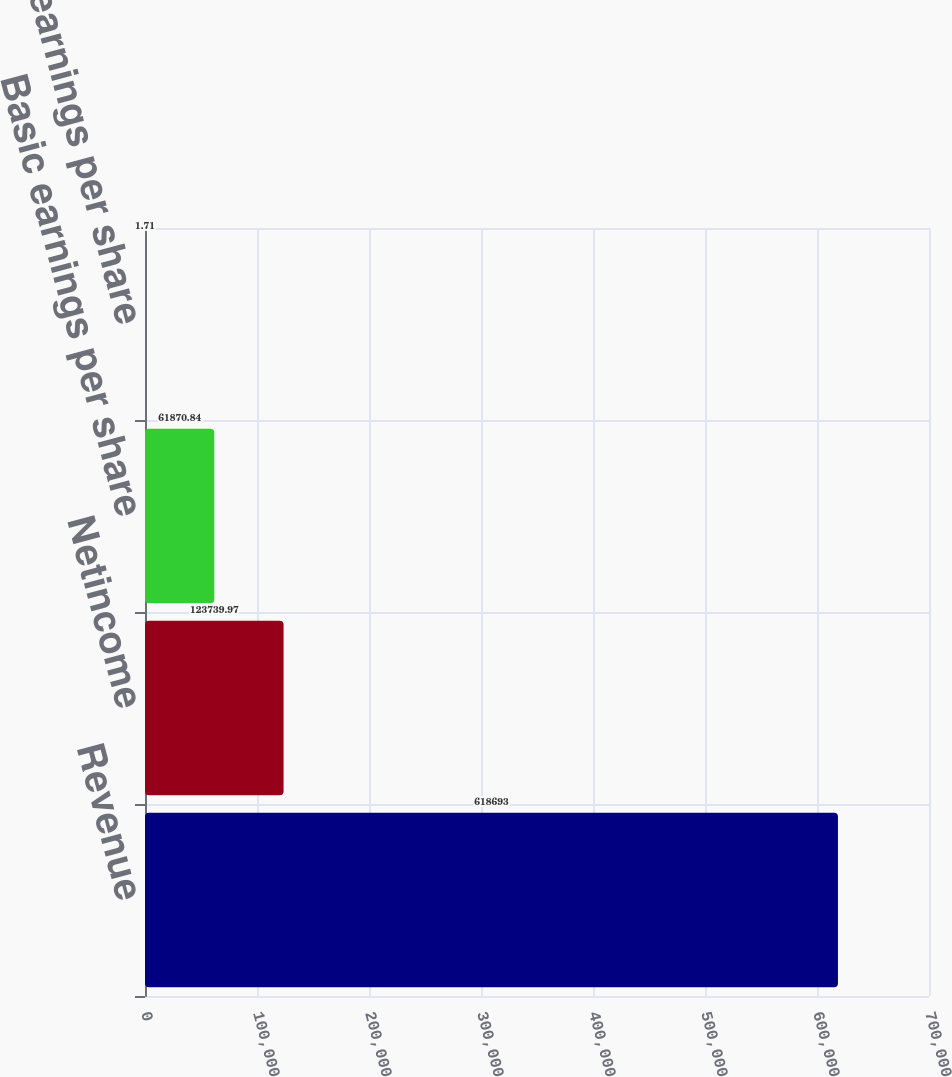Convert chart. <chart><loc_0><loc_0><loc_500><loc_500><bar_chart><fcel>Revenue<fcel>Netincome<fcel>Basic earnings per share<fcel>Diluted earnings per share<nl><fcel>618693<fcel>123740<fcel>61870.8<fcel>1.71<nl></chart> 